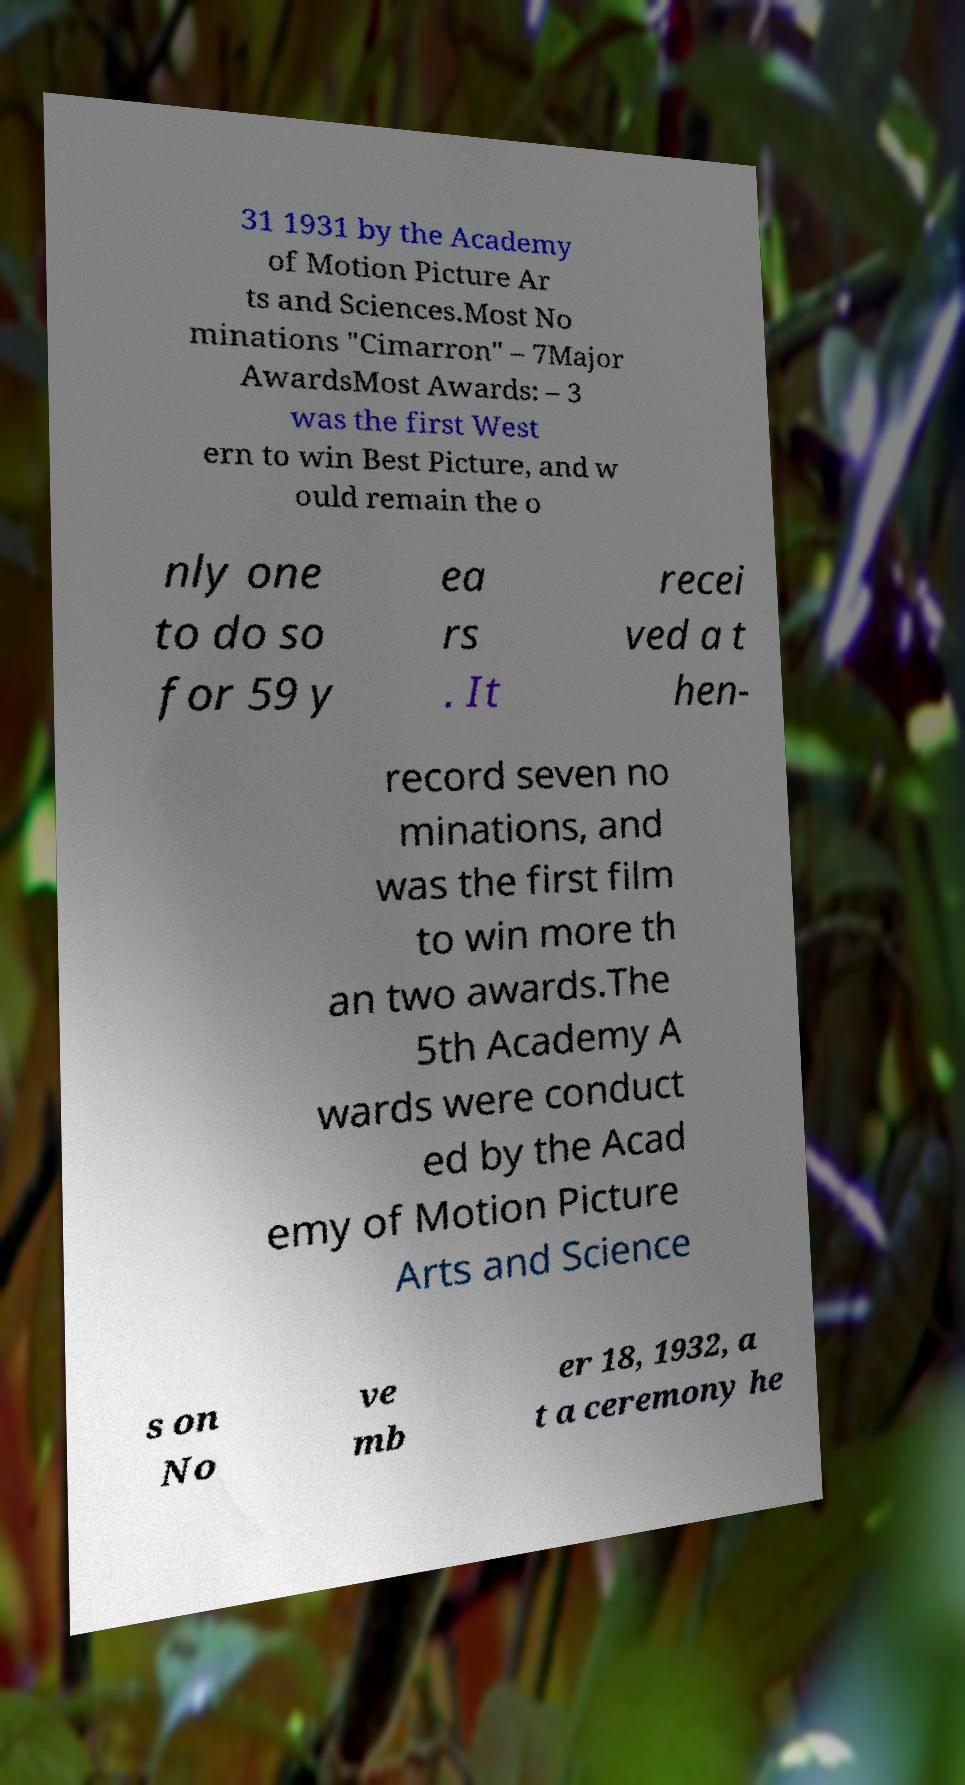Can you accurately transcribe the text from the provided image for me? 31 1931 by the Academy of Motion Picture Ar ts and Sciences.Most No minations "Cimarron" – 7Major AwardsMost Awards: – 3 was the first West ern to win Best Picture, and w ould remain the o nly one to do so for 59 y ea rs . It recei ved a t hen- record seven no minations, and was the first film to win more th an two awards.The 5th Academy A wards were conduct ed by the Acad emy of Motion Picture Arts and Science s on No ve mb er 18, 1932, a t a ceremony he 